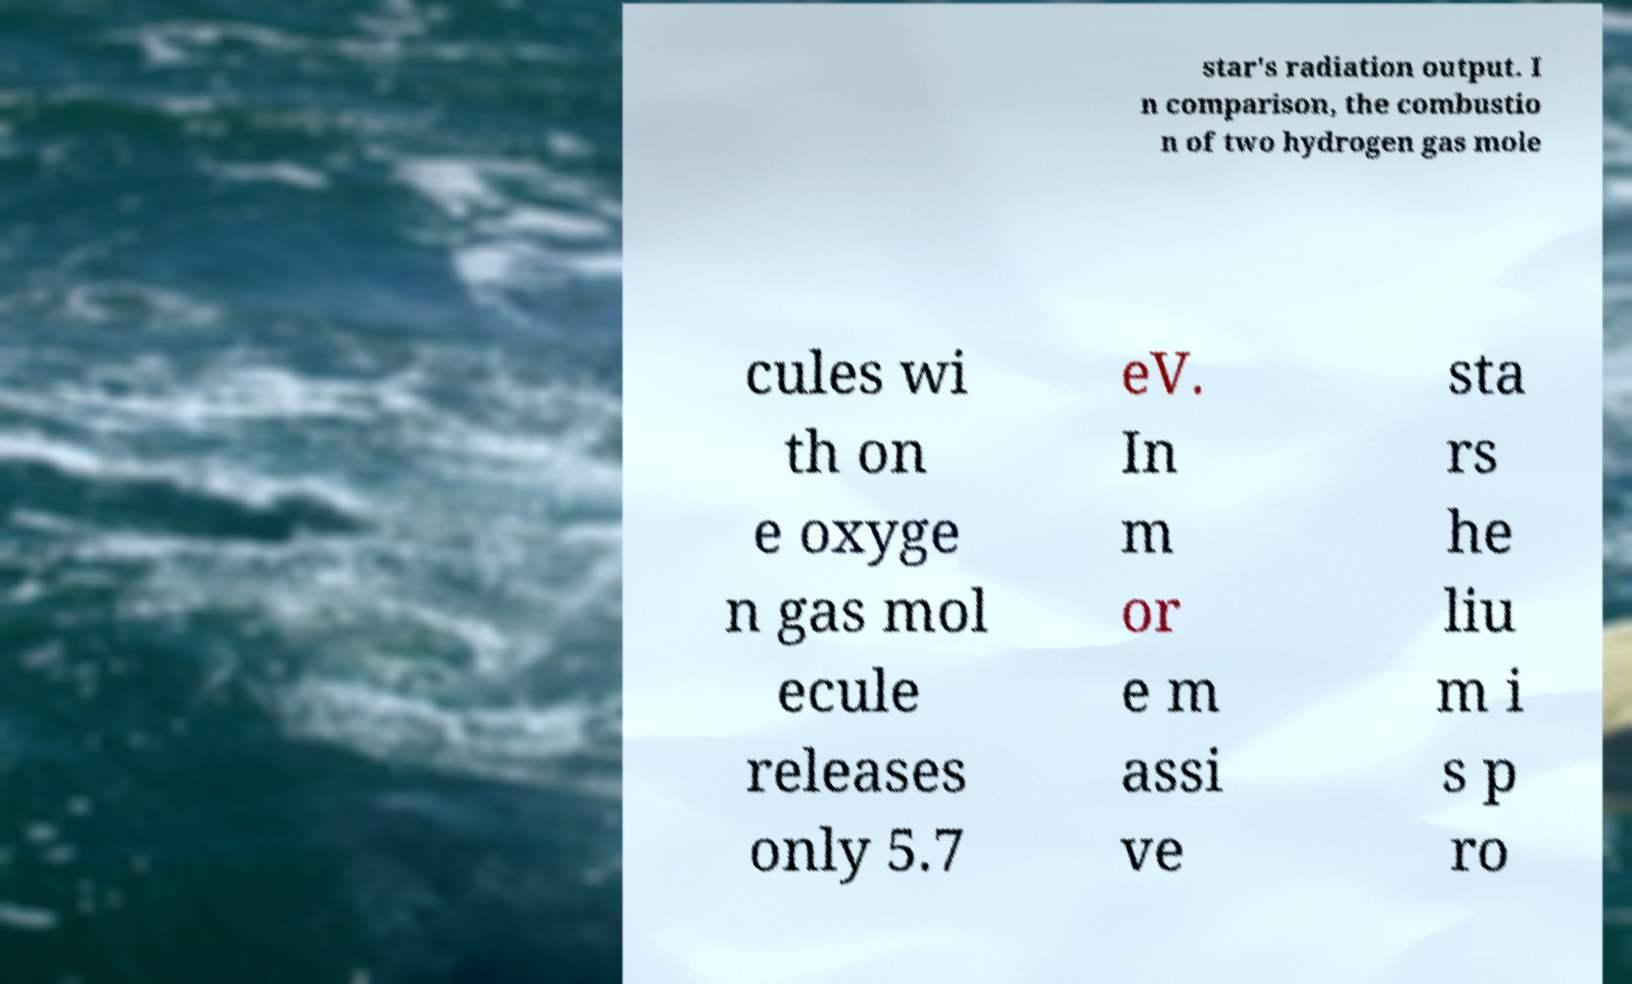Can you read and provide the text displayed in the image?This photo seems to have some interesting text. Can you extract and type it out for me? star's radiation output. I n comparison, the combustio n of two hydrogen gas mole cules wi th on e oxyge n gas mol ecule releases only 5.7 eV. In m or e m assi ve sta rs he liu m i s p ro 